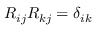<formula> <loc_0><loc_0><loc_500><loc_500>R _ { i j } R _ { k j } = \delta _ { i k }</formula> 